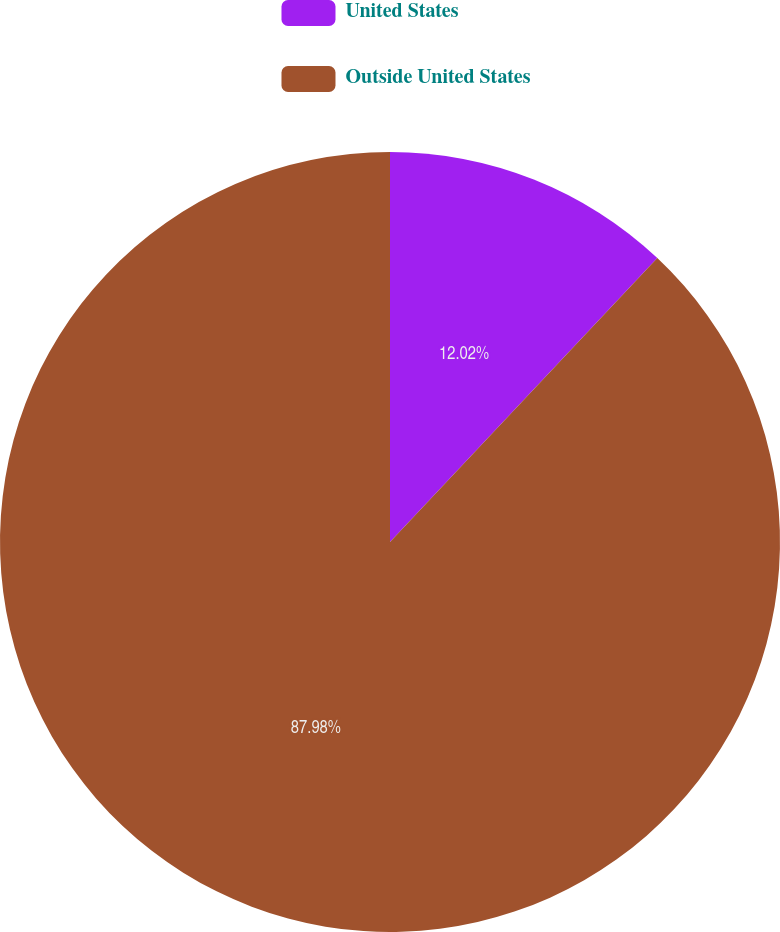Convert chart. <chart><loc_0><loc_0><loc_500><loc_500><pie_chart><fcel>United States<fcel>Outside United States<nl><fcel>12.02%<fcel>87.98%<nl></chart> 